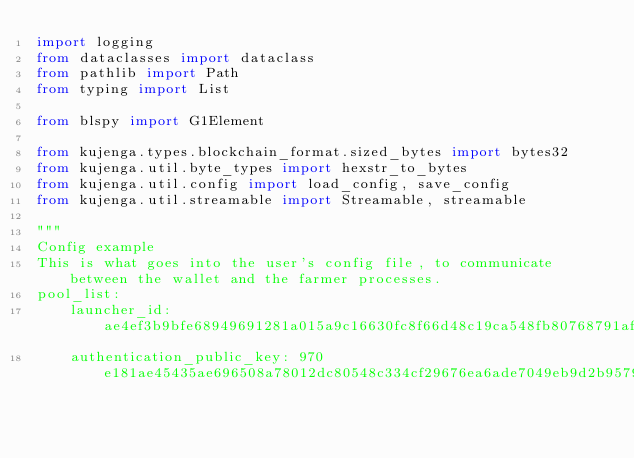<code> <loc_0><loc_0><loc_500><loc_500><_Python_>import logging
from dataclasses import dataclass
from pathlib import Path
from typing import List

from blspy import G1Element

from kujenga.types.blockchain_format.sized_bytes import bytes32
from kujenga.util.byte_types import hexstr_to_bytes
from kujenga.util.config import load_config, save_config
from kujenga.util.streamable import Streamable, streamable

"""
Config example
This is what goes into the user's config file, to communicate between the wallet and the farmer processes.
pool_list:
    launcher_id: ae4ef3b9bfe68949691281a015a9c16630fc8f66d48c19ca548fb80768791afa
    authentication_public_key: 970e181ae45435ae696508a78012dc80548c334cf29676ea6ade7049eb9d2b9579cc30cb44c3fd68d35a250cfbc69e29</code> 